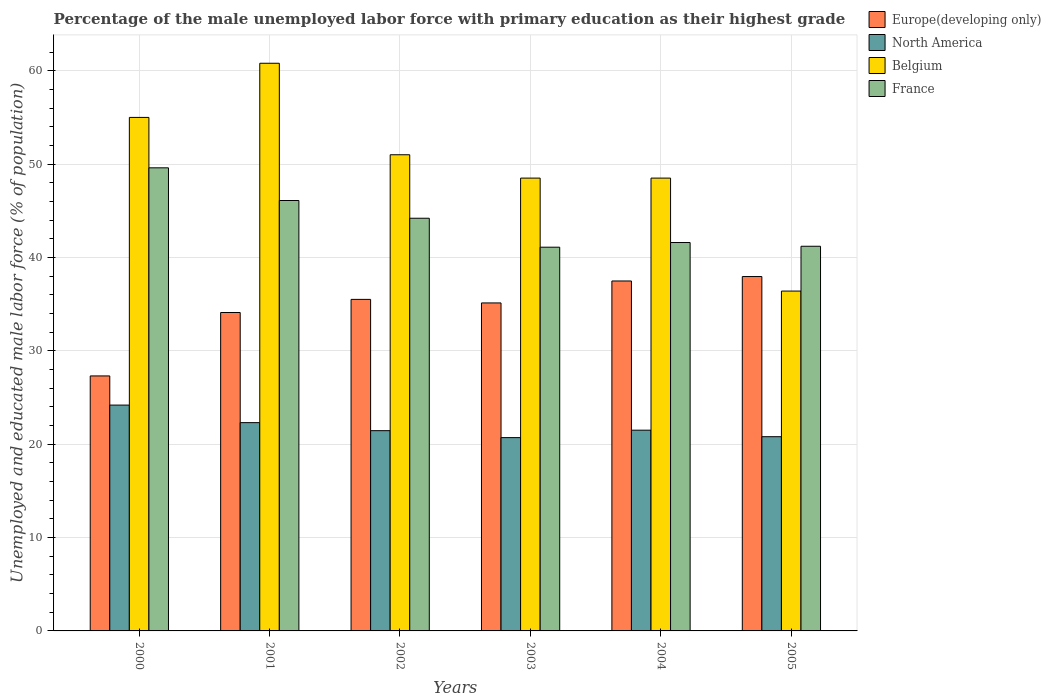How many groups of bars are there?
Provide a succinct answer. 6. What is the label of the 2nd group of bars from the left?
Offer a very short reply. 2001. What is the percentage of the unemployed male labor force with primary education in North America in 2005?
Your response must be concise. 20.8. Across all years, what is the maximum percentage of the unemployed male labor force with primary education in Europe(developing only)?
Give a very brief answer. 37.96. Across all years, what is the minimum percentage of the unemployed male labor force with primary education in Belgium?
Provide a succinct answer. 36.4. In which year was the percentage of the unemployed male labor force with primary education in France maximum?
Your answer should be compact. 2000. In which year was the percentage of the unemployed male labor force with primary education in Belgium minimum?
Your answer should be very brief. 2005. What is the total percentage of the unemployed male labor force with primary education in France in the graph?
Provide a short and direct response. 263.8. What is the difference between the percentage of the unemployed male labor force with primary education in Belgium in 2000 and that in 2005?
Your answer should be very brief. 18.6. What is the difference between the percentage of the unemployed male labor force with primary education in North America in 2001 and the percentage of the unemployed male labor force with primary education in France in 2002?
Offer a very short reply. -21.89. What is the average percentage of the unemployed male labor force with primary education in Europe(developing only) per year?
Provide a short and direct response. 34.58. In the year 2001, what is the difference between the percentage of the unemployed male labor force with primary education in Belgium and percentage of the unemployed male labor force with primary education in North America?
Give a very brief answer. 38.49. What is the ratio of the percentage of the unemployed male labor force with primary education in Belgium in 2000 to that in 2002?
Give a very brief answer. 1.08. Is the percentage of the unemployed male labor force with primary education in North America in 2000 less than that in 2003?
Offer a very short reply. No. What is the difference between the highest and the second highest percentage of the unemployed male labor force with primary education in Belgium?
Offer a very short reply. 5.8. What is the difference between the highest and the lowest percentage of the unemployed male labor force with primary education in France?
Your answer should be compact. 8.5. Is the sum of the percentage of the unemployed male labor force with primary education in North America in 2000 and 2001 greater than the maximum percentage of the unemployed male labor force with primary education in Belgium across all years?
Offer a very short reply. No. Is it the case that in every year, the sum of the percentage of the unemployed male labor force with primary education in Belgium and percentage of the unemployed male labor force with primary education in North America is greater than the percentage of the unemployed male labor force with primary education in Europe(developing only)?
Ensure brevity in your answer.  Yes. How many bars are there?
Your response must be concise. 24. What is the difference between two consecutive major ticks on the Y-axis?
Give a very brief answer. 10. Are the values on the major ticks of Y-axis written in scientific E-notation?
Ensure brevity in your answer.  No. Does the graph contain any zero values?
Give a very brief answer. No. Does the graph contain grids?
Provide a short and direct response. Yes. How are the legend labels stacked?
Give a very brief answer. Vertical. What is the title of the graph?
Provide a succinct answer. Percentage of the male unemployed labor force with primary education as their highest grade. What is the label or title of the X-axis?
Provide a short and direct response. Years. What is the label or title of the Y-axis?
Ensure brevity in your answer.  Unemployed and educated male labor force (% of population). What is the Unemployed and educated male labor force (% of population) in Europe(developing only) in 2000?
Offer a very short reply. 27.31. What is the Unemployed and educated male labor force (% of population) of North America in 2000?
Give a very brief answer. 24.19. What is the Unemployed and educated male labor force (% of population) of France in 2000?
Offer a very short reply. 49.6. What is the Unemployed and educated male labor force (% of population) in Europe(developing only) in 2001?
Keep it short and to the point. 34.1. What is the Unemployed and educated male labor force (% of population) in North America in 2001?
Your response must be concise. 22.31. What is the Unemployed and educated male labor force (% of population) in Belgium in 2001?
Offer a very short reply. 60.8. What is the Unemployed and educated male labor force (% of population) of France in 2001?
Keep it short and to the point. 46.1. What is the Unemployed and educated male labor force (% of population) in Europe(developing only) in 2002?
Your answer should be very brief. 35.51. What is the Unemployed and educated male labor force (% of population) of North America in 2002?
Keep it short and to the point. 21.45. What is the Unemployed and educated male labor force (% of population) of Belgium in 2002?
Give a very brief answer. 51. What is the Unemployed and educated male labor force (% of population) in France in 2002?
Keep it short and to the point. 44.2. What is the Unemployed and educated male labor force (% of population) in Europe(developing only) in 2003?
Offer a terse response. 35.13. What is the Unemployed and educated male labor force (% of population) of North America in 2003?
Make the answer very short. 20.7. What is the Unemployed and educated male labor force (% of population) in Belgium in 2003?
Your response must be concise. 48.5. What is the Unemployed and educated male labor force (% of population) of France in 2003?
Your response must be concise. 41.1. What is the Unemployed and educated male labor force (% of population) in Europe(developing only) in 2004?
Keep it short and to the point. 37.48. What is the Unemployed and educated male labor force (% of population) in North America in 2004?
Give a very brief answer. 21.5. What is the Unemployed and educated male labor force (% of population) in Belgium in 2004?
Make the answer very short. 48.5. What is the Unemployed and educated male labor force (% of population) of France in 2004?
Keep it short and to the point. 41.6. What is the Unemployed and educated male labor force (% of population) of Europe(developing only) in 2005?
Make the answer very short. 37.96. What is the Unemployed and educated male labor force (% of population) of North America in 2005?
Your response must be concise. 20.8. What is the Unemployed and educated male labor force (% of population) of Belgium in 2005?
Offer a very short reply. 36.4. What is the Unemployed and educated male labor force (% of population) of France in 2005?
Your response must be concise. 41.2. Across all years, what is the maximum Unemployed and educated male labor force (% of population) of Europe(developing only)?
Your answer should be compact. 37.96. Across all years, what is the maximum Unemployed and educated male labor force (% of population) of North America?
Make the answer very short. 24.19. Across all years, what is the maximum Unemployed and educated male labor force (% of population) in Belgium?
Your answer should be compact. 60.8. Across all years, what is the maximum Unemployed and educated male labor force (% of population) of France?
Your response must be concise. 49.6. Across all years, what is the minimum Unemployed and educated male labor force (% of population) in Europe(developing only)?
Make the answer very short. 27.31. Across all years, what is the minimum Unemployed and educated male labor force (% of population) of North America?
Give a very brief answer. 20.7. Across all years, what is the minimum Unemployed and educated male labor force (% of population) of Belgium?
Keep it short and to the point. 36.4. Across all years, what is the minimum Unemployed and educated male labor force (% of population) in France?
Provide a succinct answer. 41.1. What is the total Unemployed and educated male labor force (% of population) of Europe(developing only) in the graph?
Keep it short and to the point. 207.49. What is the total Unemployed and educated male labor force (% of population) of North America in the graph?
Keep it short and to the point. 130.95. What is the total Unemployed and educated male labor force (% of population) in Belgium in the graph?
Provide a succinct answer. 300.2. What is the total Unemployed and educated male labor force (% of population) of France in the graph?
Your answer should be compact. 263.8. What is the difference between the Unemployed and educated male labor force (% of population) of Europe(developing only) in 2000 and that in 2001?
Offer a terse response. -6.79. What is the difference between the Unemployed and educated male labor force (% of population) in North America in 2000 and that in 2001?
Offer a terse response. 1.88. What is the difference between the Unemployed and educated male labor force (% of population) in Belgium in 2000 and that in 2001?
Provide a short and direct response. -5.8. What is the difference between the Unemployed and educated male labor force (% of population) of Europe(developing only) in 2000 and that in 2002?
Your answer should be compact. -8.2. What is the difference between the Unemployed and educated male labor force (% of population) in North America in 2000 and that in 2002?
Give a very brief answer. 2.74. What is the difference between the Unemployed and educated male labor force (% of population) in Belgium in 2000 and that in 2002?
Provide a short and direct response. 4. What is the difference between the Unemployed and educated male labor force (% of population) in France in 2000 and that in 2002?
Offer a very short reply. 5.4. What is the difference between the Unemployed and educated male labor force (% of population) of Europe(developing only) in 2000 and that in 2003?
Make the answer very short. -7.82. What is the difference between the Unemployed and educated male labor force (% of population) of North America in 2000 and that in 2003?
Give a very brief answer. 3.48. What is the difference between the Unemployed and educated male labor force (% of population) in Europe(developing only) in 2000 and that in 2004?
Give a very brief answer. -10.17. What is the difference between the Unemployed and educated male labor force (% of population) of North America in 2000 and that in 2004?
Ensure brevity in your answer.  2.69. What is the difference between the Unemployed and educated male labor force (% of population) of France in 2000 and that in 2004?
Offer a terse response. 8. What is the difference between the Unemployed and educated male labor force (% of population) in Europe(developing only) in 2000 and that in 2005?
Offer a terse response. -10.64. What is the difference between the Unemployed and educated male labor force (% of population) in North America in 2000 and that in 2005?
Give a very brief answer. 3.38. What is the difference between the Unemployed and educated male labor force (% of population) in France in 2000 and that in 2005?
Provide a succinct answer. 8.4. What is the difference between the Unemployed and educated male labor force (% of population) in Europe(developing only) in 2001 and that in 2002?
Ensure brevity in your answer.  -1.41. What is the difference between the Unemployed and educated male labor force (% of population) in North America in 2001 and that in 2002?
Your response must be concise. 0.86. What is the difference between the Unemployed and educated male labor force (% of population) in France in 2001 and that in 2002?
Offer a very short reply. 1.9. What is the difference between the Unemployed and educated male labor force (% of population) of Europe(developing only) in 2001 and that in 2003?
Offer a terse response. -1.03. What is the difference between the Unemployed and educated male labor force (% of population) in North America in 2001 and that in 2003?
Your answer should be compact. 1.6. What is the difference between the Unemployed and educated male labor force (% of population) of France in 2001 and that in 2003?
Make the answer very short. 5. What is the difference between the Unemployed and educated male labor force (% of population) in Europe(developing only) in 2001 and that in 2004?
Offer a terse response. -3.38. What is the difference between the Unemployed and educated male labor force (% of population) of North America in 2001 and that in 2004?
Your response must be concise. 0.81. What is the difference between the Unemployed and educated male labor force (% of population) of Europe(developing only) in 2001 and that in 2005?
Offer a very short reply. -3.85. What is the difference between the Unemployed and educated male labor force (% of population) of North America in 2001 and that in 2005?
Provide a short and direct response. 1.51. What is the difference between the Unemployed and educated male labor force (% of population) of Belgium in 2001 and that in 2005?
Provide a short and direct response. 24.4. What is the difference between the Unemployed and educated male labor force (% of population) of France in 2001 and that in 2005?
Give a very brief answer. 4.9. What is the difference between the Unemployed and educated male labor force (% of population) in Europe(developing only) in 2002 and that in 2003?
Offer a terse response. 0.38. What is the difference between the Unemployed and educated male labor force (% of population) in North America in 2002 and that in 2003?
Give a very brief answer. 0.74. What is the difference between the Unemployed and educated male labor force (% of population) of Belgium in 2002 and that in 2003?
Provide a succinct answer. 2.5. What is the difference between the Unemployed and educated male labor force (% of population) in Europe(developing only) in 2002 and that in 2004?
Ensure brevity in your answer.  -1.97. What is the difference between the Unemployed and educated male labor force (% of population) of North America in 2002 and that in 2004?
Your response must be concise. -0.05. What is the difference between the Unemployed and educated male labor force (% of population) in Europe(developing only) in 2002 and that in 2005?
Provide a short and direct response. -2.45. What is the difference between the Unemployed and educated male labor force (% of population) in North America in 2002 and that in 2005?
Keep it short and to the point. 0.65. What is the difference between the Unemployed and educated male labor force (% of population) of Belgium in 2002 and that in 2005?
Offer a very short reply. 14.6. What is the difference between the Unemployed and educated male labor force (% of population) in Europe(developing only) in 2003 and that in 2004?
Your answer should be compact. -2.35. What is the difference between the Unemployed and educated male labor force (% of population) in North America in 2003 and that in 2004?
Offer a terse response. -0.8. What is the difference between the Unemployed and educated male labor force (% of population) in Belgium in 2003 and that in 2004?
Make the answer very short. 0. What is the difference between the Unemployed and educated male labor force (% of population) of Europe(developing only) in 2003 and that in 2005?
Your response must be concise. -2.83. What is the difference between the Unemployed and educated male labor force (% of population) of North America in 2003 and that in 2005?
Offer a terse response. -0.1. What is the difference between the Unemployed and educated male labor force (% of population) of Belgium in 2003 and that in 2005?
Your answer should be very brief. 12.1. What is the difference between the Unemployed and educated male labor force (% of population) of Europe(developing only) in 2004 and that in 2005?
Keep it short and to the point. -0.47. What is the difference between the Unemployed and educated male labor force (% of population) in North America in 2004 and that in 2005?
Your answer should be very brief. 0.7. What is the difference between the Unemployed and educated male labor force (% of population) in Europe(developing only) in 2000 and the Unemployed and educated male labor force (% of population) in North America in 2001?
Your answer should be compact. 5. What is the difference between the Unemployed and educated male labor force (% of population) of Europe(developing only) in 2000 and the Unemployed and educated male labor force (% of population) of Belgium in 2001?
Offer a terse response. -33.49. What is the difference between the Unemployed and educated male labor force (% of population) of Europe(developing only) in 2000 and the Unemployed and educated male labor force (% of population) of France in 2001?
Give a very brief answer. -18.79. What is the difference between the Unemployed and educated male labor force (% of population) of North America in 2000 and the Unemployed and educated male labor force (% of population) of Belgium in 2001?
Your answer should be very brief. -36.61. What is the difference between the Unemployed and educated male labor force (% of population) of North America in 2000 and the Unemployed and educated male labor force (% of population) of France in 2001?
Your response must be concise. -21.91. What is the difference between the Unemployed and educated male labor force (% of population) in Belgium in 2000 and the Unemployed and educated male labor force (% of population) in France in 2001?
Your answer should be compact. 8.9. What is the difference between the Unemployed and educated male labor force (% of population) of Europe(developing only) in 2000 and the Unemployed and educated male labor force (% of population) of North America in 2002?
Your answer should be very brief. 5.86. What is the difference between the Unemployed and educated male labor force (% of population) of Europe(developing only) in 2000 and the Unemployed and educated male labor force (% of population) of Belgium in 2002?
Give a very brief answer. -23.69. What is the difference between the Unemployed and educated male labor force (% of population) in Europe(developing only) in 2000 and the Unemployed and educated male labor force (% of population) in France in 2002?
Make the answer very short. -16.89. What is the difference between the Unemployed and educated male labor force (% of population) of North America in 2000 and the Unemployed and educated male labor force (% of population) of Belgium in 2002?
Offer a very short reply. -26.81. What is the difference between the Unemployed and educated male labor force (% of population) of North America in 2000 and the Unemployed and educated male labor force (% of population) of France in 2002?
Provide a short and direct response. -20.01. What is the difference between the Unemployed and educated male labor force (% of population) in Belgium in 2000 and the Unemployed and educated male labor force (% of population) in France in 2002?
Give a very brief answer. 10.8. What is the difference between the Unemployed and educated male labor force (% of population) in Europe(developing only) in 2000 and the Unemployed and educated male labor force (% of population) in North America in 2003?
Offer a very short reply. 6.61. What is the difference between the Unemployed and educated male labor force (% of population) of Europe(developing only) in 2000 and the Unemployed and educated male labor force (% of population) of Belgium in 2003?
Offer a terse response. -21.19. What is the difference between the Unemployed and educated male labor force (% of population) of Europe(developing only) in 2000 and the Unemployed and educated male labor force (% of population) of France in 2003?
Your answer should be compact. -13.79. What is the difference between the Unemployed and educated male labor force (% of population) of North America in 2000 and the Unemployed and educated male labor force (% of population) of Belgium in 2003?
Keep it short and to the point. -24.31. What is the difference between the Unemployed and educated male labor force (% of population) of North America in 2000 and the Unemployed and educated male labor force (% of population) of France in 2003?
Offer a terse response. -16.91. What is the difference between the Unemployed and educated male labor force (% of population) in Belgium in 2000 and the Unemployed and educated male labor force (% of population) in France in 2003?
Provide a succinct answer. 13.9. What is the difference between the Unemployed and educated male labor force (% of population) in Europe(developing only) in 2000 and the Unemployed and educated male labor force (% of population) in North America in 2004?
Provide a succinct answer. 5.81. What is the difference between the Unemployed and educated male labor force (% of population) of Europe(developing only) in 2000 and the Unemployed and educated male labor force (% of population) of Belgium in 2004?
Offer a terse response. -21.19. What is the difference between the Unemployed and educated male labor force (% of population) of Europe(developing only) in 2000 and the Unemployed and educated male labor force (% of population) of France in 2004?
Your answer should be compact. -14.29. What is the difference between the Unemployed and educated male labor force (% of population) of North America in 2000 and the Unemployed and educated male labor force (% of population) of Belgium in 2004?
Make the answer very short. -24.31. What is the difference between the Unemployed and educated male labor force (% of population) in North America in 2000 and the Unemployed and educated male labor force (% of population) in France in 2004?
Give a very brief answer. -17.41. What is the difference between the Unemployed and educated male labor force (% of population) in Europe(developing only) in 2000 and the Unemployed and educated male labor force (% of population) in North America in 2005?
Your answer should be very brief. 6.51. What is the difference between the Unemployed and educated male labor force (% of population) of Europe(developing only) in 2000 and the Unemployed and educated male labor force (% of population) of Belgium in 2005?
Your response must be concise. -9.09. What is the difference between the Unemployed and educated male labor force (% of population) of Europe(developing only) in 2000 and the Unemployed and educated male labor force (% of population) of France in 2005?
Offer a terse response. -13.89. What is the difference between the Unemployed and educated male labor force (% of population) in North America in 2000 and the Unemployed and educated male labor force (% of population) in Belgium in 2005?
Make the answer very short. -12.21. What is the difference between the Unemployed and educated male labor force (% of population) in North America in 2000 and the Unemployed and educated male labor force (% of population) in France in 2005?
Your answer should be very brief. -17.01. What is the difference between the Unemployed and educated male labor force (% of population) in Belgium in 2000 and the Unemployed and educated male labor force (% of population) in France in 2005?
Keep it short and to the point. 13.8. What is the difference between the Unemployed and educated male labor force (% of population) of Europe(developing only) in 2001 and the Unemployed and educated male labor force (% of population) of North America in 2002?
Ensure brevity in your answer.  12.66. What is the difference between the Unemployed and educated male labor force (% of population) in Europe(developing only) in 2001 and the Unemployed and educated male labor force (% of population) in Belgium in 2002?
Provide a succinct answer. -16.9. What is the difference between the Unemployed and educated male labor force (% of population) in Europe(developing only) in 2001 and the Unemployed and educated male labor force (% of population) in France in 2002?
Provide a succinct answer. -10.1. What is the difference between the Unemployed and educated male labor force (% of population) of North America in 2001 and the Unemployed and educated male labor force (% of population) of Belgium in 2002?
Provide a succinct answer. -28.69. What is the difference between the Unemployed and educated male labor force (% of population) of North America in 2001 and the Unemployed and educated male labor force (% of population) of France in 2002?
Make the answer very short. -21.89. What is the difference between the Unemployed and educated male labor force (% of population) in Belgium in 2001 and the Unemployed and educated male labor force (% of population) in France in 2002?
Provide a succinct answer. 16.6. What is the difference between the Unemployed and educated male labor force (% of population) in Europe(developing only) in 2001 and the Unemployed and educated male labor force (% of population) in North America in 2003?
Give a very brief answer. 13.4. What is the difference between the Unemployed and educated male labor force (% of population) in Europe(developing only) in 2001 and the Unemployed and educated male labor force (% of population) in Belgium in 2003?
Your answer should be compact. -14.4. What is the difference between the Unemployed and educated male labor force (% of population) of Europe(developing only) in 2001 and the Unemployed and educated male labor force (% of population) of France in 2003?
Provide a succinct answer. -7. What is the difference between the Unemployed and educated male labor force (% of population) of North America in 2001 and the Unemployed and educated male labor force (% of population) of Belgium in 2003?
Give a very brief answer. -26.19. What is the difference between the Unemployed and educated male labor force (% of population) of North America in 2001 and the Unemployed and educated male labor force (% of population) of France in 2003?
Provide a short and direct response. -18.79. What is the difference between the Unemployed and educated male labor force (% of population) of Europe(developing only) in 2001 and the Unemployed and educated male labor force (% of population) of North America in 2004?
Offer a very short reply. 12.6. What is the difference between the Unemployed and educated male labor force (% of population) of Europe(developing only) in 2001 and the Unemployed and educated male labor force (% of population) of Belgium in 2004?
Provide a short and direct response. -14.4. What is the difference between the Unemployed and educated male labor force (% of population) of Europe(developing only) in 2001 and the Unemployed and educated male labor force (% of population) of France in 2004?
Provide a short and direct response. -7.5. What is the difference between the Unemployed and educated male labor force (% of population) of North America in 2001 and the Unemployed and educated male labor force (% of population) of Belgium in 2004?
Offer a very short reply. -26.19. What is the difference between the Unemployed and educated male labor force (% of population) of North America in 2001 and the Unemployed and educated male labor force (% of population) of France in 2004?
Give a very brief answer. -19.29. What is the difference between the Unemployed and educated male labor force (% of population) in Belgium in 2001 and the Unemployed and educated male labor force (% of population) in France in 2004?
Make the answer very short. 19.2. What is the difference between the Unemployed and educated male labor force (% of population) in Europe(developing only) in 2001 and the Unemployed and educated male labor force (% of population) in North America in 2005?
Ensure brevity in your answer.  13.3. What is the difference between the Unemployed and educated male labor force (% of population) of Europe(developing only) in 2001 and the Unemployed and educated male labor force (% of population) of Belgium in 2005?
Offer a terse response. -2.3. What is the difference between the Unemployed and educated male labor force (% of population) in Europe(developing only) in 2001 and the Unemployed and educated male labor force (% of population) in France in 2005?
Provide a short and direct response. -7.1. What is the difference between the Unemployed and educated male labor force (% of population) of North America in 2001 and the Unemployed and educated male labor force (% of population) of Belgium in 2005?
Make the answer very short. -14.09. What is the difference between the Unemployed and educated male labor force (% of population) of North America in 2001 and the Unemployed and educated male labor force (% of population) of France in 2005?
Offer a terse response. -18.89. What is the difference between the Unemployed and educated male labor force (% of population) of Belgium in 2001 and the Unemployed and educated male labor force (% of population) of France in 2005?
Offer a terse response. 19.6. What is the difference between the Unemployed and educated male labor force (% of population) in Europe(developing only) in 2002 and the Unemployed and educated male labor force (% of population) in North America in 2003?
Your response must be concise. 14.8. What is the difference between the Unemployed and educated male labor force (% of population) in Europe(developing only) in 2002 and the Unemployed and educated male labor force (% of population) in Belgium in 2003?
Your answer should be compact. -12.99. What is the difference between the Unemployed and educated male labor force (% of population) in Europe(developing only) in 2002 and the Unemployed and educated male labor force (% of population) in France in 2003?
Your response must be concise. -5.59. What is the difference between the Unemployed and educated male labor force (% of population) in North America in 2002 and the Unemployed and educated male labor force (% of population) in Belgium in 2003?
Offer a very short reply. -27.05. What is the difference between the Unemployed and educated male labor force (% of population) of North America in 2002 and the Unemployed and educated male labor force (% of population) of France in 2003?
Keep it short and to the point. -19.65. What is the difference between the Unemployed and educated male labor force (% of population) of Europe(developing only) in 2002 and the Unemployed and educated male labor force (% of population) of North America in 2004?
Your answer should be very brief. 14.01. What is the difference between the Unemployed and educated male labor force (% of population) of Europe(developing only) in 2002 and the Unemployed and educated male labor force (% of population) of Belgium in 2004?
Offer a terse response. -12.99. What is the difference between the Unemployed and educated male labor force (% of population) of Europe(developing only) in 2002 and the Unemployed and educated male labor force (% of population) of France in 2004?
Your answer should be compact. -6.09. What is the difference between the Unemployed and educated male labor force (% of population) in North America in 2002 and the Unemployed and educated male labor force (% of population) in Belgium in 2004?
Your answer should be very brief. -27.05. What is the difference between the Unemployed and educated male labor force (% of population) of North America in 2002 and the Unemployed and educated male labor force (% of population) of France in 2004?
Offer a very short reply. -20.15. What is the difference between the Unemployed and educated male labor force (% of population) in Belgium in 2002 and the Unemployed and educated male labor force (% of population) in France in 2004?
Offer a terse response. 9.4. What is the difference between the Unemployed and educated male labor force (% of population) in Europe(developing only) in 2002 and the Unemployed and educated male labor force (% of population) in North America in 2005?
Your answer should be compact. 14.71. What is the difference between the Unemployed and educated male labor force (% of population) of Europe(developing only) in 2002 and the Unemployed and educated male labor force (% of population) of Belgium in 2005?
Ensure brevity in your answer.  -0.89. What is the difference between the Unemployed and educated male labor force (% of population) of Europe(developing only) in 2002 and the Unemployed and educated male labor force (% of population) of France in 2005?
Offer a very short reply. -5.69. What is the difference between the Unemployed and educated male labor force (% of population) in North America in 2002 and the Unemployed and educated male labor force (% of population) in Belgium in 2005?
Provide a short and direct response. -14.95. What is the difference between the Unemployed and educated male labor force (% of population) in North America in 2002 and the Unemployed and educated male labor force (% of population) in France in 2005?
Offer a very short reply. -19.75. What is the difference between the Unemployed and educated male labor force (% of population) in Belgium in 2002 and the Unemployed and educated male labor force (% of population) in France in 2005?
Your answer should be very brief. 9.8. What is the difference between the Unemployed and educated male labor force (% of population) in Europe(developing only) in 2003 and the Unemployed and educated male labor force (% of population) in North America in 2004?
Your answer should be very brief. 13.63. What is the difference between the Unemployed and educated male labor force (% of population) in Europe(developing only) in 2003 and the Unemployed and educated male labor force (% of population) in Belgium in 2004?
Keep it short and to the point. -13.37. What is the difference between the Unemployed and educated male labor force (% of population) in Europe(developing only) in 2003 and the Unemployed and educated male labor force (% of population) in France in 2004?
Your response must be concise. -6.47. What is the difference between the Unemployed and educated male labor force (% of population) in North America in 2003 and the Unemployed and educated male labor force (% of population) in Belgium in 2004?
Offer a terse response. -27.8. What is the difference between the Unemployed and educated male labor force (% of population) in North America in 2003 and the Unemployed and educated male labor force (% of population) in France in 2004?
Provide a succinct answer. -20.9. What is the difference between the Unemployed and educated male labor force (% of population) of Belgium in 2003 and the Unemployed and educated male labor force (% of population) of France in 2004?
Your answer should be compact. 6.9. What is the difference between the Unemployed and educated male labor force (% of population) of Europe(developing only) in 2003 and the Unemployed and educated male labor force (% of population) of North America in 2005?
Give a very brief answer. 14.33. What is the difference between the Unemployed and educated male labor force (% of population) in Europe(developing only) in 2003 and the Unemployed and educated male labor force (% of population) in Belgium in 2005?
Your response must be concise. -1.27. What is the difference between the Unemployed and educated male labor force (% of population) in Europe(developing only) in 2003 and the Unemployed and educated male labor force (% of population) in France in 2005?
Your answer should be compact. -6.07. What is the difference between the Unemployed and educated male labor force (% of population) of North America in 2003 and the Unemployed and educated male labor force (% of population) of Belgium in 2005?
Ensure brevity in your answer.  -15.7. What is the difference between the Unemployed and educated male labor force (% of population) in North America in 2003 and the Unemployed and educated male labor force (% of population) in France in 2005?
Make the answer very short. -20.5. What is the difference between the Unemployed and educated male labor force (% of population) in Europe(developing only) in 2004 and the Unemployed and educated male labor force (% of population) in North America in 2005?
Your answer should be compact. 16.68. What is the difference between the Unemployed and educated male labor force (% of population) in Europe(developing only) in 2004 and the Unemployed and educated male labor force (% of population) in Belgium in 2005?
Make the answer very short. 1.08. What is the difference between the Unemployed and educated male labor force (% of population) in Europe(developing only) in 2004 and the Unemployed and educated male labor force (% of population) in France in 2005?
Make the answer very short. -3.72. What is the difference between the Unemployed and educated male labor force (% of population) of North America in 2004 and the Unemployed and educated male labor force (% of population) of Belgium in 2005?
Keep it short and to the point. -14.9. What is the difference between the Unemployed and educated male labor force (% of population) of North America in 2004 and the Unemployed and educated male labor force (% of population) of France in 2005?
Your answer should be compact. -19.7. What is the difference between the Unemployed and educated male labor force (% of population) in Belgium in 2004 and the Unemployed and educated male labor force (% of population) in France in 2005?
Make the answer very short. 7.3. What is the average Unemployed and educated male labor force (% of population) in Europe(developing only) per year?
Make the answer very short. 34.58. What is the average Unemployed and educated male labor force (% of population) of North America per year?
Offer a very short reply. 21.83. What is the average Unemployed and educated male labor force (% of population) in Belgium per year?
Provide a succinct answer. 50.03. What is the average Unemployed and educated male labor force (% of population) of France per year?
Ensure brevity in your answer.  43.97. In the year 2000, what is the difference between the Unemployed and educated male labor force (% of population) in Europe(developing only) and Unemployed and educated male labor force (% of population) in North America?
Your answer should be compact. 3.12. In the year 2000, what is the difference between the Unemployed and educated male labor force (% of population) of Europe(developing only) and Unemployed and educated male labor force (% of population) of Belgium?
Offer a terse response. -27.69. In the year 2000, what is the difference between the Unemployed and educated male labor force (% of population) of Europe(developing only) and Unemployed and educated male labor force (% of population) of France?
Keep it short and to the point. -22.29. In the year 2000, what is the difference between the Unemployed and educated male labor force (% of population) in North America and Unemployed and educated male labor force (% of population) in Belgium?
Your answer should be very brief. -30.81. In the year 2000, what is the difference between the Unemployed and educated male labor force (% of population) of North America and Unemployed and educated male labor force (% of population) of France?
Make the answer very short. -25.41. In the year 2001, what is the difference between the Unemployed and educated male labor force (% of population) in Europe(developing only) and Unemployed and educated male labor force (% of population) in North America?
Keep it short and to the point. 11.79. In the year 2001, what is the difference between the Unemployed and educated male labor force (% of population) of Europe(developing only) and Unemployed and educated male labor force (% of population) of Belgium?
Offer a very short reply. -26.7. In the year 2001, what is the difference between the Unemployed and educated male labor force (% of population) of Europe(developing only) and Unemployed and educated male labor force (% of population) of France?
Provide a succinct answer. -12. In the year 2001, what is the difference between the Unemployed and educated male labor force (% of population) in North America and Unemployed and educated male labor force (% of population) in Belgium?
Give a very brief answer. -38.49. In the year 2001, what is the difference between the Unemployed and educated male labor force (% of population) in North America and Unemployed and educated male labor force (% of population) in France?
Offer a very short reply. -23.79. In the year 2002, what is the difference between the Unemployed and educated male labor force (% of population) in Europe(developing only) and Unemployed and educated male labor force (% of population) in North America?
Keep it short and to the point. 14.06. In the year 2002, what is the difference between the Unemployed and educated male labor force (% of population) in Europe(developing only) and Unemployed and educated male labor force (% of population) in Belgium?
Provide a short and direct response. -15.49. In the year 2002, what is the difference between the Unemployed and educated male labor force (% of population) of Europe(developing only) and Unemployed and educated male labor force (% of population) of France?
Your response must be concise. -8.69. In the year 2002, what is the difference between the Unemployed and educated male labor force (% of population) in North America and Unemployed and educated male labor force (% of population) in Belgium?
Your answer should be very brief. -29.55. In the year 2002, what is the difference between the Unemployed and educated male labor force (% of population) in North America and Unemployed and educated male labor force (% of population) in France?
Keep it short and to the point. -22.75. In the year 2002, what is the difference between the Unemployed and educated male labor force (% of population) of Belgium and Unemployed and educated male labor force (% of population) of France?
Provide a succinct answer. 6.8. In the year 2003, what is the difference between the Unemployed and educated male labor force (% of population) of Europe(developing only) and Unemployed and educated male labor force (% of population) of North America?
Offer a terse response. 14.43. In the year 2003, what is the difference between the Unemployed and educated male labor force (% of population) in Europe(developing only) and Unemployed and educated male labor force (% of population) in Belgium?
Provide a succinct answer. -13.37. In the year 2003, what is the difference between the Unemployed and educated male labor force (% of population) in Europe(developing only) and Unemployed and educated male labor force (% of population) in France?
Your answer should be very brief. -5.97. In the year 2003, what is the difference between the Unemployed and educated male labor force (% of population) in North America and Unemployed and educated male labor force (% of population) in Belgium?
Provide a short and direct response. -27.8. In the year 2003, what is the difference between the Unemployed and educated male labor force (% of population) in North America and Unemployed and educated male labor force (% of population) in France?
Your answer should be compact. -20.4. In the year 2004, what is the difference between the Unemployed and educated male labor force (% of population) of Europe(developing only) and Unemployed and educated male labor force (% of population) of North America?
Keep it short and to the point. 15.98. In the year 2004, what is the difference between the Unemployed and educated male labor force (% of population) of Europe(developing only) and Unemployed and educated male labor force (% of population) of Belgium?
Give a very brief answer. -11.02. In the year 2004, what is the difference between the Unemployed and educated male labor force (% of population) of Europe(developing only) and Unemployed and educated male labor force (% of population) of France?
Your answer should be very brief. -4.12. In the year 2004, what is the difference between the Unemployed and educated male labor force (% of population) of North America and Unemployed and educated male labor force (% of population) of Belgium?
Your response must be concise. -27. In the year 2004, what is the difference between the Unemployed and educated male labor force (% of population) in North America and Unemployed and educated male labor force (% of population) in France?
Your answer should be very brief. -20.1. In the year 2004, what is the difference between the Unemployed and educated male labor force (% of population) of Belgium and Unemployed and educated male labor force (% of population) of France?
Provide a succinct answer. 6.9. In the year 2005, what is the difference between the Unemployed and educated male labor force (% of population) in Europe(developing only) and Unemployed and educated male labor force (% of population) in North America?
Offer a very short reply. 17.15. In the year 2005, what is the difference between the Unemployed and educated male labor force (% of population) in Europe(developing only) and Unemployed and educated male labor force (% of population) in Belgium?
Provide a succinct answer. 1.56. In the year 2005, what is the difference between the Unemployed and educated male labor force (% of population) in Europe(developing only) and Unemployed and educated male labor force (% of population) in France?
Offer a terse response. -3.24. In the year 2005, what is the difference between the Unemployed and educated male labor force (% of population) of North America and Unemployed and educated male labor force (% of population) of Belgium?
Provide a succinct answer. -15.6. In the year 2005, what is the difference between the Unemployed and educated male labor force (% of population) of North America and Unemployed and educated male labor force (% of population) of France?
Make the answer very short. -20.4. In the year 2005, what is the difference between the Unemployed and educated male labor force (% of population) of Belgium and Unemployed and educated male labor force (% of population) of France?
Offer a terse response. -4.8. What is the ratio of the Unemployed and educated male labor force (% of population) of Europe(developing only) in 2000 to that in 2001?
Offer a very short reply. 0.8. What is the ratio of the Unemployed and educated male labor force (% of population) in North America in 2000 to that in 2001?
Keep it short and to the point. 1.08. What is the ratio of the Unemployed and educated male labor force (% of population) in Belgium in 2000 to that in 2001?
Your answer should be compact. 0.9. What is the ratio of the Unemployed and educated male labor force (% of population) in France in 2000 to that in 2001?
Make the answer very short. 1.08. What is the ratio of the Unemployed and educated male labor force (% of population) in Europe(developing only) in 2000 to that in 2002?
Your response must be concise. 0.77. What is the ratio of the Unemployed and educated male labor force (% of population) in North America in 2000 to that in 2002?
Your response must be concise. 1.13. What is the ratio of the Unemployed and educated male labor force (% of population) of Belgium in 2000 to that in 2002?
Offer a terse response. 1.08. What is the ratio of the Unemployed and educated male labor force (% of population) of France in 2000 to that in 2002?
Make the answer very short. 1.12. What is the ratio of the Unemployed and educated male labor force (% of population) of Europe(developing only) in 2000 to that in 2003?
Give a very brief answer. 0.78. What is the ratio of the Unemployed and educated male labor force (% of population) of North America in 2000 to that in 2003?
Your answer should be compact. 1.17. What is the ratio of the Unemployed and educated male labor force (% of population) of Belgium in 2000 to that in 2003?
Offer a terse response. 1.13. What is the ratio of the Unemployed and educated male labor force (% of population) in France in 2000 to that in 2003?
Give a very brief answer. 1.21. What is the ratio of the Unemployed and educated male labor force (% of population) in Europe(developing only) in 2000 to that in 2004?
Offer a very short reply. 0.73. What is the ratio of the Unemployed and educated male labor force (% of population) in Belgium in 2000 to that in 2004?
Offer a very short reply. 1.13. What is the ratio of the Unemployed and educated male labor force (% of population) of France in 2000 to that in 2004?
Provide a short and direct response. 1.19. What is the ratio of the Unemployed and educated male labor force (% of population) in Europe(developing only) in 2000 to that in 2005?
Your answer should be very brief. 0.72. What is the ratio of the Unemployed and educated male labor force (% of population) in North America in 2000 to that in 2005?
Provide a succinct answer. 1.16. What is the ratio of the Unemployed and educated male labor force (% of population) of Belgium in 2000 to that in 2005?
Provide a succinct answer. 1.51. What is the ratio of the Unemployed and educated male labor force (% of population) of France in 2000 to that in 2005?
Your answer should be compact. 1.2. What is the ratio of the Unemployed and educated male labor force (% of population) of Europe(developing only) in 2001 to that in 2002?
Provide a succinct answer. 0.96. What is the ratio of the Unemployed and educated male labor force (% of population) of North America in 2001 to that in 2002?
Offer a terse response. 1.04. What is the ratio of the Unemployed and educated male labor force (% of population) of Belgium in 2001 to that in 2002?
Offer a very short reply. 1.19. What is the ratio of the Unemployed and educated male labor force (% of population) in France in 2001 to that in 2002?
Give a very brief answer. 1.04. What is the ratio of the Unemployed and educated male labor force (% of population) in Europe(developing only) in 2001 to that in 2003?
Provide a succinct answer. 0.97. What is the ratio of the Unemployed and educated male labor force (% of population) in North America in 2001 to that in 2003?
Provide a short and direct response. 1.08. What is the ratio of the Unemployed and educated male labor force (% of population) in Belgium in 2001 to that in 2003?
Ensure brevity in your answer.  1.25. What is the ratio of the Unemployed and educated male labor force (% of population) of France in 2001 to that in 2003?
Your answer should be very brief. 1.12. What is the ratio of the Unemployed and educated male labor force (% of population) of Europe(developing only) in 2001 to that in 2004?
Offer a terse response. 0.91. What is the ratio of the Unemployed and educated male labor force (% of population) in North America in 2001 to that in 2004?
Make the answer very short. 1.04. What is the ratio of the Unemployed and educated male labor force (% of population) in Belgium in 2001 to that in 2004?
Ensure brevity in your answer.  1.25. What is the ratio of the Unemployed and educated male labor force (% of population) in France in 2001 to that in 2004?
Your answer should be compact. 1.11. What is the ratio of the Unemployed and educated male labor force (% of population) of Europe(developing only) in 2001 to that in 2005?
Make the answer very short. 0.9. What is the ratio of the Unemployed and educated male labor force (% of population) in North America in 2001 to that in 2005?
Provide a short and direct response. 1.07. What is the ratio of the Unemployed and educated male labor force (% of population) of Belgium in 2001 to that in 2005?
Ensure brevity in your answer.  1.67. What is the ratio of the Unemployed and educated male labor force (% of population) in France in 2001 to that in 2005?
Provide a short and direct response. 1.12. What is the ratio of the Unemployed and educated male labor force (% of population) of Europe(developing only) in 2002 to that in 2003?
Keep it short and to the point. 1.01. What is the ratio of the Unemployed and educated male labor force (% of population) of North America in 2002 to that in 2003?
Give a very brief answer. 1.04. What is the ratio of the Unemployed and educated male labor force (% of population) in Belgium in 2002 to that in 2003?
Make the answer very short. 1.05. What is the ratio of the Unemployed and educated male labor force (% of population) of France in 2002 to that in 2003?
Offer a very short reply. 1.08. What is the ratio of the Unemployed and educated male labor force (% of population) in North America in 2002 to that in 2004?
Keep it short and to the point. 1. What is the ratio of the Unemployed and educated male labor force (% of population) in Belgium in 2002 to that in 2004?
Ensure brevity in your answer.  1.05. What is the ratio of the Unemployed and educated male labor force (% of population) in Europe(developing only) in 2002 to that in 2005?
Provide a short and direct response. 0.94. What is the ratio of the Unemployed and educated male labor force (% of population) of North America in 2002 to that in 2005?
Give a very brief answer. 1.03. What is the ratio of the Unemployed and educated male labor force (% of population) of Belgium in 2002 to that in 2005?
Your response must be concise. 1.4. What is the ratio of the Unemployed and educated male labor force (% of population) in France in 2002 to that in 2005?
Provide a short and direct response. 1.07. What is the ratio of the Unemployed and educated male labor force (% of population) of Europe(developing only) in 2003 to that in 2004?
Offer a terse response. 0.94. What is the ratio of the Unemployed and educated male labor force (% of population) in North America in 2003 to that in 2004?
Your answer should be compact. 0.96. What is the ratio of the Unemployed and educated male labor force (% of population) in Belgium in 2003 to that in 2004?
Provide a succinct answer. 1. What is the ratio of the Unemployed and educated male labor force (% of population) of Europe(developing only) in 2003 to that in 2005?
Give a very brief answer. 0.93. What is the ratio of the Unemployed and educated male labor force (% of population) of North America in 2003 to that in 2005?
Provide a succinct answer. 1. What is the ratio of the Unemployed and educated male labor force (% of population) of Belgium in 2003 to that in 2005?
Make the answer very short. 1.33. What is the ratio of the Unemployed and educated male labor force (% of population) in Europe(developing only) in 2004 to that in 2005?
Make the answer very short. 0.99. What is the ratio of the Unemployed and educated male labor force (% of population) in North America in 2004 to that in 2005?
Ensure brevity in your answer.  1.03. What is the ratio of the Unemployed and educated male labor force (% of population) in Belgium in 2004 to that in 2005?
Make the answer very short. 1.33. What is the ratio of the Unemployed and educated male labor force (% of population) in France in 2004 to that in 2005?
Offer a very short reply. 1.01. What is the difference between the highest and the second highest Unemployed and educated male labor force (% of population) of Europe(developing only)?
Ensure brevity in your answer.  0.47. What is the difference between the highest and the second highest Unemployed and educated male labor force (% of population) of North America?
Make the answer very short. 1.88. What is the difference between the highest and the second highest Unemployed and educated male labor force (% of population) of Belgium?
Your answer should be compact. 5.8. What is the difference between the highest and the second highest Unemployed and educated male labor force (% of population) in France?
Keep it short and to the point. 3.5. What is the difference between the highest and the lowest Unemployed and educated male labor force (% of population) in Europe(developing only)?
Keep it short and to the point. 10.64. What is the difference between the highest and the lowest Unemployed and educated male labor force (% of population) in North America?
Ensure brevity in your answer.  3.48. What is the difference between the highest and the lowest Unemployed and educated male labor force (% of population) of Belgium?
Provide a succinct answer. 24.4. What is the difference between the highest and the lowest Unemployed and educated male labor force (% of population) of France?
Offer a very short reply. 8.5. 